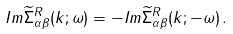<formula> <loc_0><loc_0><loc_500><loc_500>I m \widetilde { \Sigma } ^ { R } _ { \alpha \beta } ( k ; \omega ) = - I m \widetilde { \Sigma } ^ { R } _ { \alpha \beta } ( k ; - \omega ) \, .</formula> 